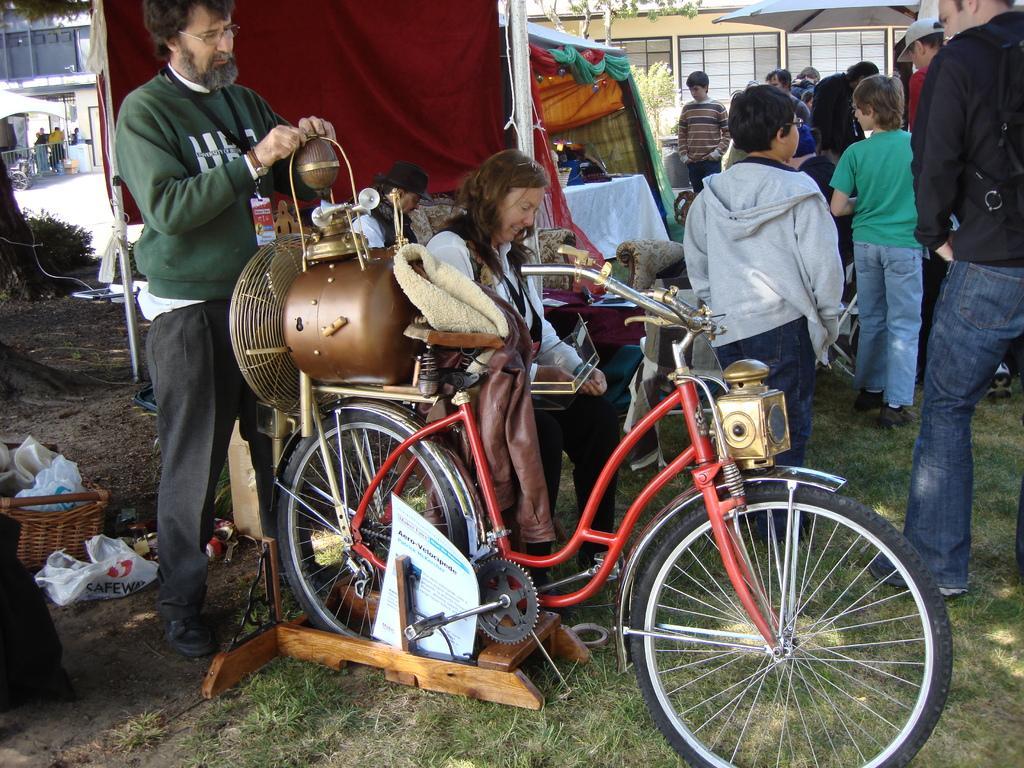In one or two sentences, can you explain what this image depicts? This picture shows few people standing and we see a woman seated and we see a bicycle with motor fixed to it on the back and we see buildings and grass on the ground and we see a basket with carry bags in it and we see a man wore spectacles on his face. 